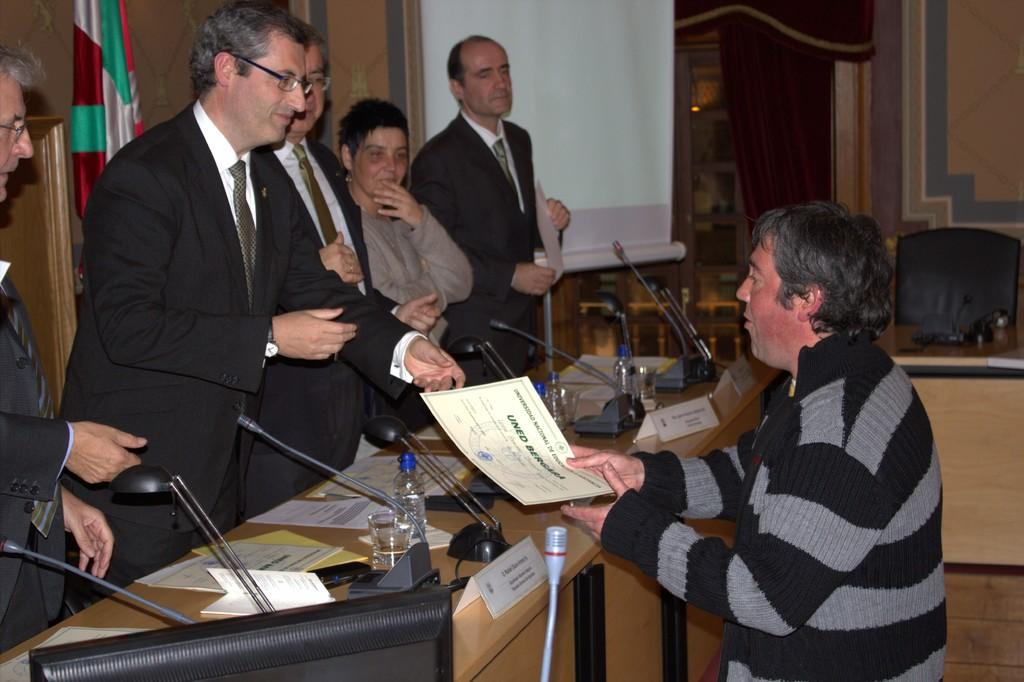<image>
Render a clear and concise summary of the photo. One man hands a certificate with the text "Uned Bergara" to another man. 